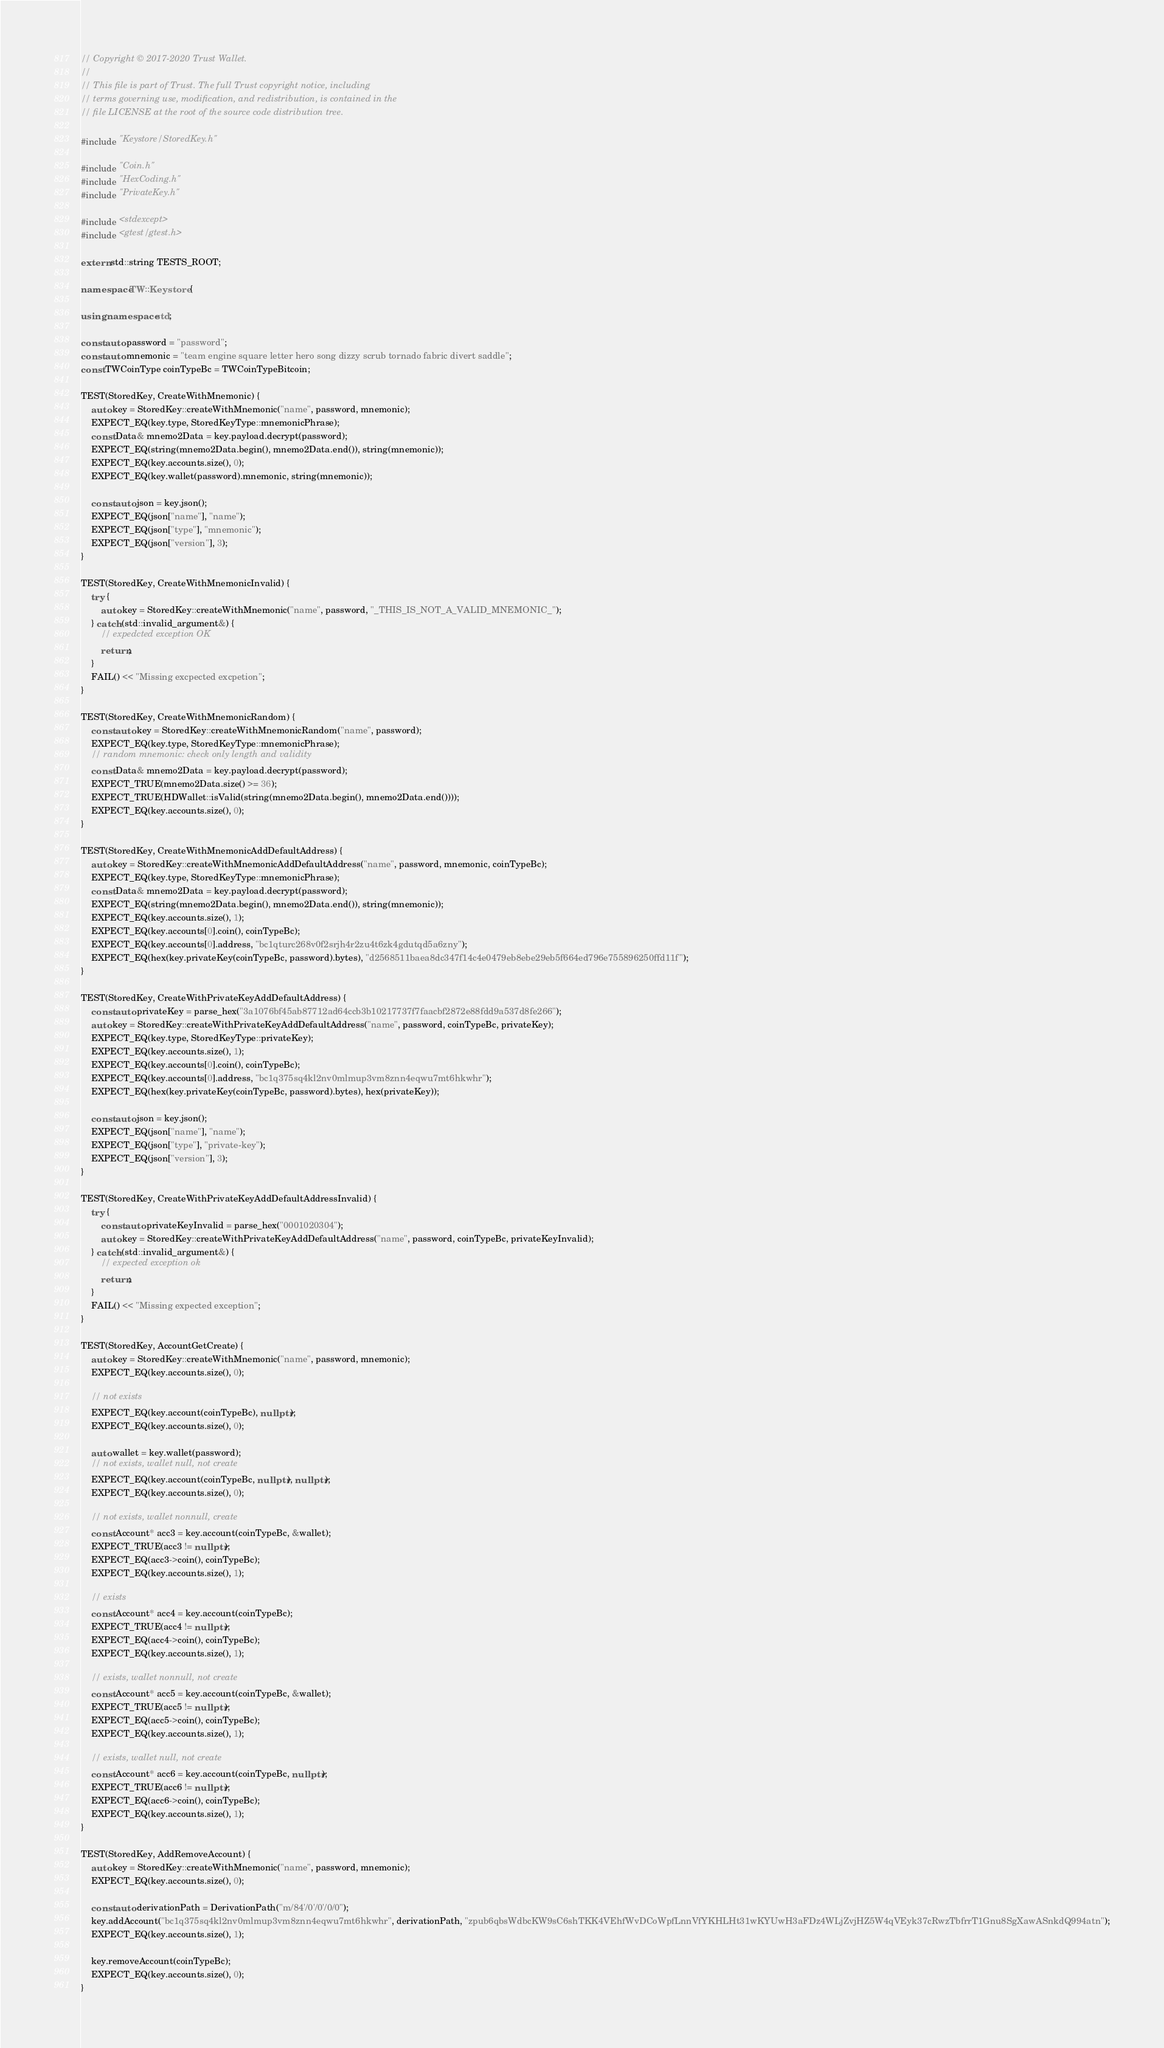<code> <loc_0><loc_0><loc_500><loc_500><_C++_>// Copyright © 2017-2020 Trust Wallet.
//
// This file is part of Trust. The full Trust copyright notice, including
// terms governing use, modification, and redistribution, is contained in the
// file LICENSE at the root of the source code distribution tree.

#include "Keystore/StoredKey.h"

#include "Coin.h"
#include "HexCoding.h"
#include "PrivateKey.h"

#include <stdexcept>
#include <gtest/gtest.h>

extern std::string TESTS_ROOT;

namespace TW::Keystore {

using namespace std;

const auto password = "password";
const auto mnemonic = "team engine square letter hero song dizzy scrub tornado fabric divert saddle";
const TWCoinType coinTypeBc = TWCoinTypeBitcoin;

TEST(StoredKey, CreateWithMnemonic) {
    auto key = StoredKey::createWithMnemonic("name", password, mnemonic);
    EXPECT_EQ(key.type, StoredKeyType::mnemonicPhrase);
    const Data& mnemo2Data = key.payload.decrypt(password);
    EXPECT_EQ(string(mnemo2Data.begin(), mnemo2Data.end()), string(mnemonic));
    EXPECT_EQ(key.accounts.size(), 0);
    EXPECT_EQ(key.wallet(password).mnemonic, string(mnemonic));

    const auto json = key.json();
    EXPECT_EQ(json["name"], "name");
    EXPECT_EQ(json["type"], "mnemonic");
    EXPECT_EQ(json["version"], 3);
}

TEST(StoredKey, CreateWithMnemonicInvalid) {
    try {
        auto key = StoredKey::createWithMnemonic("name", password, "_THIS_IS_NOT_A_VALID_MNEMONIC_");
    } catch (std::invalid_argument&) {
        // expedcted exception OK
        return;
    }
    FAIL() << "Missing excpected excpetion";
}

TEST(StoredKey, CreateWithMnemonicRandom) {
    const auto key = StoredKey::createWithMnemonicRandom("name", password);
    EXPECT_EQ(key.type, StoredKeyType::mnemonicPhrase);
    // random mnemonic: check only length and validity
    const Data& mnemo2Data = key.payload.decrypt(password);
    EXPECT_TRUE(mnemo2Data.size() >= 36);
    EXPECT_TRUE(HDWallet::isValid(string(mnemo2Data.begin(), mnemo2Data.end())));
    EXPECT_EQ(key.accounts.size(), 0);
}

TEST(StoredKey, CreateWithMnemonicAddDefaultAddress) {
    auto key = StoredKey::createWithMnemonicAddDefaultAddress("name", password, mnemonic, coinTypeBc);
    EXPECT_EQ(key.type, StoredKeyType::mnemonicPhrase);
    const Data& mnemo2Data = key.payload.decrypt(password);
    EXPECT_EQ(string(mnemo2Data.begin(), mnemo2Data.end()), string(mnemonic));
    EXPECT_EQ(key.accounts.size(), 1);
    EXPECT_EQ(key.accounts[0].coin(), coinTypeBc);
    EXPECT_EQ(key.accounts[0].address, "bc1qturc268v0f2srjh4r2zu4t6zk4gdutqd5a6zny");
    EXPECT_EQ(hex(key.privateKey(coinTypeBc, password).bytes), "d2568511baea8dc347f14c4e0479eb8ebe29eb5f664ed796e755896250ffd11f");
}

TEST(StoredKey, CreateWithPrivateKeyAddDefaultAddress) {
    const auto privateKey = parse_hex("3a1076bf45ab87712ad64ccb3b10217737f7faacbf2872e88fdd9a537d8fe266");
    auto key = StoredKey::createWithPrivateKeyAddDefaultAddress("name", password, coinTypeBc, privateKey);
    EXPECT_EQ(key.type, StoredKeyType::privateKey);
    EXPECT_EQ(key.accounts.size(), 1);
    EXPECT_EQ(key.accounts[0].coin(), coinTypeBc);
    EXPECT_EQ(key.accounts[0].address, "bc1q375sq4kl2nv0mlmup3vm8znn4eqwu7mt6hkwhr");
    EXPECT_EQ(hex(key.privateKey(coinTypeBc, password).bytes), hex(privateKey));

    const auto json = key.json();
    EXPECT_EQ(json["name"], "name");
    EXPECT_EQ(json["type"], "private-key");
    EXPECT_EQ(json["version"], 3);
}

TEST(StoredKey, CreateWithPrivateKeyAddDefaultAddressInvalid) {
    try {
        const auto privateKeyInvalid = parse_hex("0001020304");
        auto key = StoredKey::createWithPrivateKeyAddDefaultAddress("name", password, coinTypeBc, privateKeyInvalid);
    } catch (std::invalid_argument&) {
        // expected exception ok
        return;
    }
    FAIL() << "Missing expected exception";
}

TEST(StoredKey, AccountGetCreate) {
    auto key = StoredKey::createWithMnemonic("name", password, mnemonic);
    EXPECT_EQ(key.accounts.size(), 0);

    // not exists
    EXPECT_EQ(key.account(coinTypeBc), nullptr);
    EXPECT_EQ(key.accounts.size(), 0);

    auto wallet = key.wallet(password);
    // not exists, wallet null, not create
    EXPECT_EQ(key.account(coinTypeBc, nullptr), nullptr);
    EXPECT_EQ(key.accounts.size(), 0);

    // not exists, wallet nonnull, create
    const Account* acc3 = key.account(coinTypeBc, &wallet);
    EXPECT_TRUE(acc3 != nullptr);
    EXPECT_EQ(acc3->coin(), coinTypeBc); 
    EXPECT_EQ(key.accounts.size(), 1);

    // exists
    const Account* acc4 = key.account(coinTypeBc);
    EXPECT_TRUE(acc4 != nullptr);
    EXPECT_EQ(acc4->coin(), coinTypeBc); 
    EXPECT_EQ(key.accounts.size(), 1);

    // exists, wallet nonnull, not create
    const Account* acc5 = key.account(coinTypeBc, &wallet);
    EXPECT_TRUE(acc5 != nullptr);
    EXPECT_EQ(acc5->coin(), coinTypeBc); 
    EXPECT_EQ(key.accounts.size(), 1);

    // exists, wallet null, not create
    const Account* acc6 = key.account(coinTypeBc, nullptr);
    EXPECT_TRUE(acc6 != nullptr);
    EXPECT_EQ(acc6->coin(), coinTypeBc); 
    EXPECT_EQ(key.accounts.size(), 1);
}

TEST(StoredKey, AddRemoveAccount) {
    auto key = StoredKey::createWithMnemonic("name", password, mnemonic);
    EXPECT_EQ(key.accounts.size(), 0);

    const auto derivationPath = DerivationPath("m/84'/0'/0'/0/0");
    key.addAccount("bc1q375sq4kl2nv0mlmup3vm8znn4eqwu7mt6hkwhr", derivationPath, "zpub6qbsWdbcKW9sC6shTKK4VEhfWvDCoWpfLnnVfYKHLHt31wKYUwH3aFDz4WLjZvjHZ5W4qVEyk37cRwzTbfrrT1Gnu8SgXawASnkdQ994atn");
    EXPECT_EQ(key.accounts.size(), 1);

    key.removeAccount(coinTypeBc);
    EXPECT_EQ(key.accounts.size(), 0);
}
</code> 